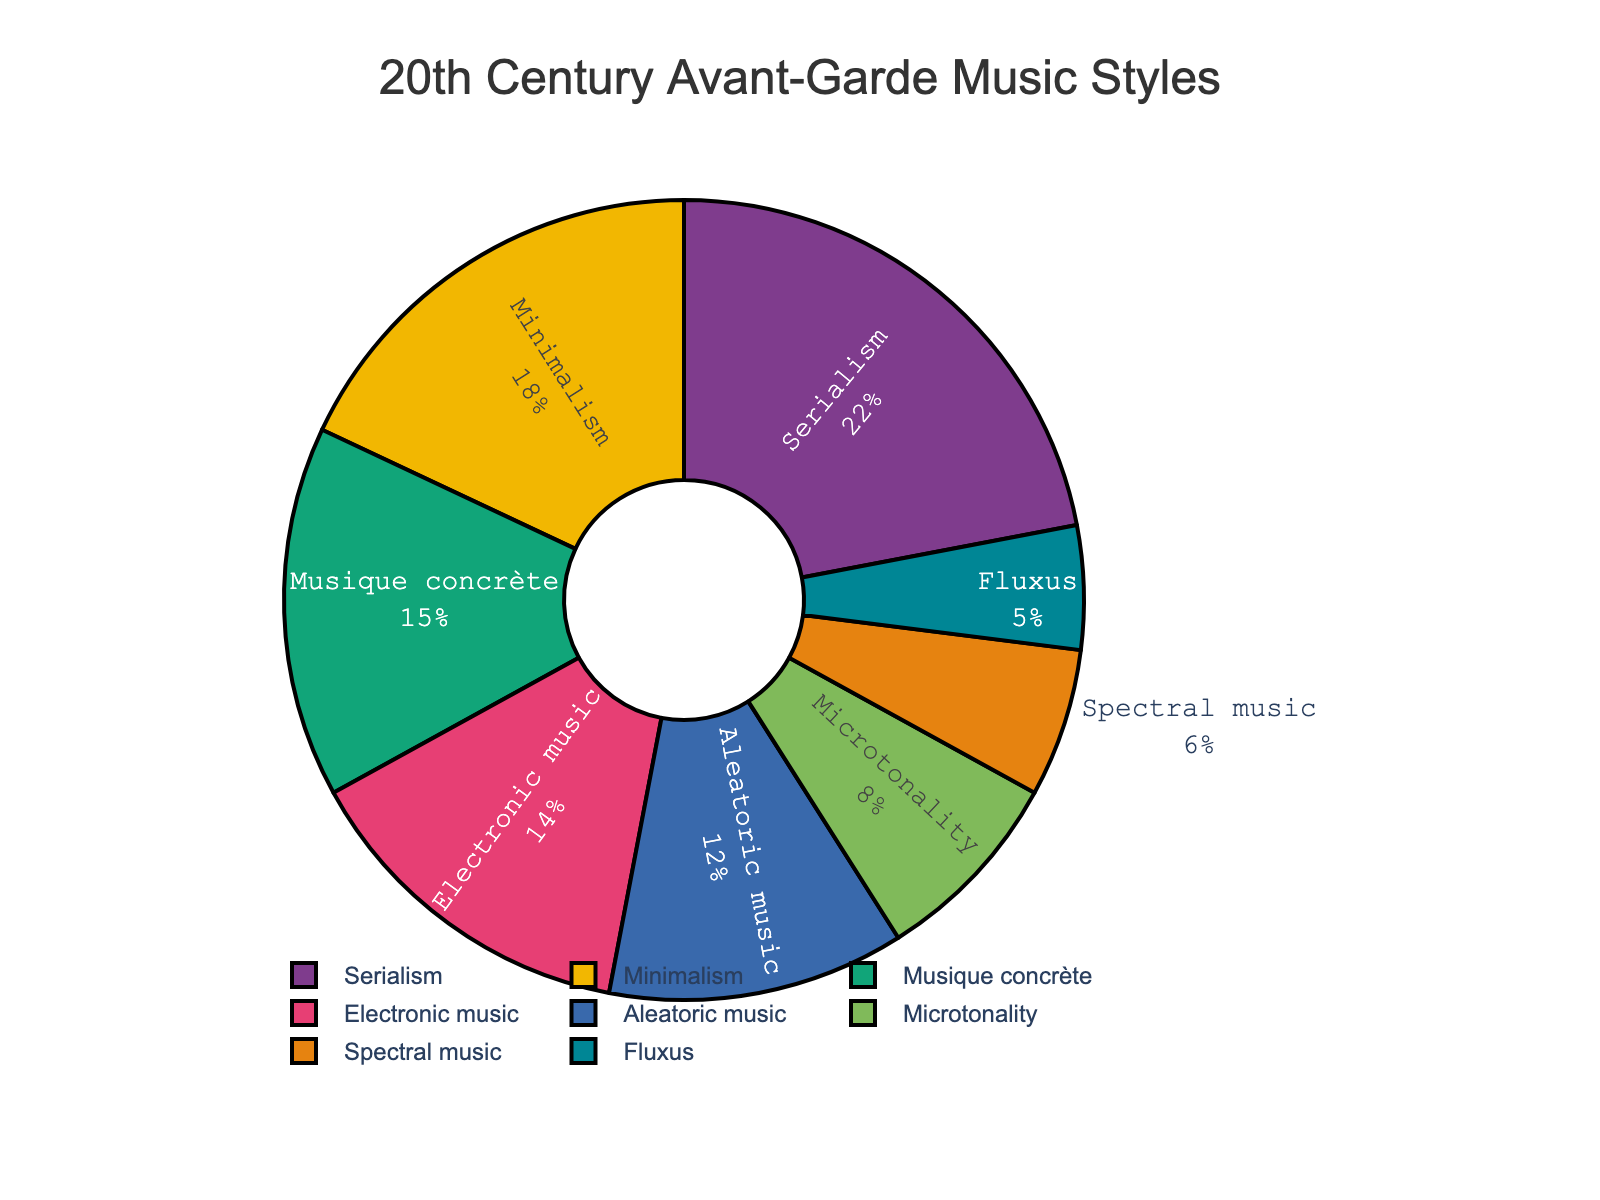Which musical style has the largest percentage in the 20th century avant-garde movement? The largest slice of the pie chart appears to belong to Serialism at 22%.
Answer: Serialism Which two musical styles combined make up 30% of the 20th century avant-garde movement? Adding up the percentages of Aleatoric music (12%) and Fluxus (5%) equals 17%, which is not enough. The next smallest slice is Microtonality (8%), which combined with Aleatoric music (12%) gives 20%. But to reach exactly 30%, you can combine Minimalism (18%) and Microtonality (8%). Adding Minimalism (18%) and Microtonality (8%) is 26%, which is also not enough. So the correct answer is Aleatoric music (12%) and Electronic music (14%).
Answer: Aleatoric music and Electronic music Which musical style has the smallest percentage in the pie chart? The smallest slice of the pie chart belongs to Fluxus at 5%.
Answer: Fluxus How many styles together make up more than 50% of the 20th century avant-garde movement? Adding up the percentages step-by-step: Serialism (22%) + Minimalism (18%) gives 40%, which is not enough. Adding Musique concrète's 15% brings the total to 55%, which is more than 50%. So, it takes three styles: Serialism (22%), Minimalism (18%), and Musique concrète (15%) to exceed 50%.
Answer: Three styles What's the difference in percentage between Serialism and Musique concrète? The percentage of Serialism is 22% and that of Musique concrète is 15%. Subtract 15 from 22 to find the difference: 22% - 15% = 7%.
Answer: 7% How does the percentage of Minimalism compare to that of Electronic music? Minimalism has a percentage of 18%, while Electronic music has a percentage of 14%. Comparing them, 18% is greater than 14%.
Answer: Minimalism has a higher percentage If you combine the percentages of Spectral music and Fluxus, what percentage do they make up together? Spectral music is at 6% and Fluxus is at 5%. Adding them: 6% + 5% = 11%.
Answer: 11% What is the average percentage of Microtonality and Aleatoric music? Microtonality is at 8% and Aleatoric music is at 12%. Adding them gives 8% + 12% = 20%. Dividing this sum by 2, the average is 20% / 2 = 10%.
Answer: 10% Compare the combined percentage of Microtonality and Fluxus with the percentage of Minimalism. Which one is higher? Microtonality is at 8% and Fluxus is at 5%, making their combined total 8% + 5% = 13%. Minimalism is at 18%. Comparing 13% with 18%, we see that 18% is higher.
Answer: Minimalism is higher 